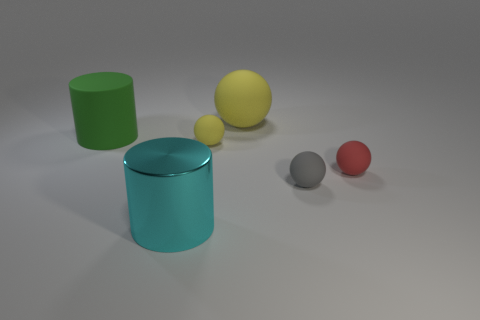Is there any other thing that is the same material as the large cyan cylinder?
Make the answer very short. No. What color is the cylinder that is made of the same material as the large ball?
Ensure brevity in your answer.  Green. Is there a big green cylinder that is in front of the ball on the left side of the sphere behind the green rubber object?
Give a very brief answer. No. Are there fewer cyan metal cylinders on the right side of the big metal cylinder than gray spheres that are behind the small gray rubber ball?
Give a very brief answer. No. How many green things have the same material as the gray thing?
Your answer should be very brief. 1. Does the gray sphere have the same size as the sphere that is behind the tiny yellow rubber ball?
Provide a succinct answer. No. What material is the thing that is the same color as the big matte sphere?
Provide a short and direct response. Rubber. There is a yellow matte object in front of the yellow rubber thing that is behind the yellow object in front of the large yellow rubber ball; what size is it?
Your response must be concise. Small. Is the number of gray rubber spheres behind the cyan cylinder greater than the number of big yellow objects that are in front of the large green matte object?
Offer a terse response. Yes. What number of large yellow rubber objects are left of the rubber ball that is in front of the small red matte thing?
Your answer should be very brief. 1. 